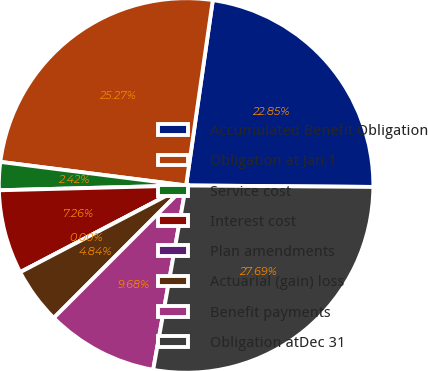<chart> <loc_0><loc_0><loc_500><loc_500><pie_chart><fcel>Accumulated Benefit Obligation<fcel>Obligation at Jan 1<fcel>Service cost<fcel>Interest cost<fcel>Plan amendments<fcel>Actuarial (gain) loss<fcel>Benefit payments<fcel>Obligation atDec 31<nl><fcel>22.85%<fcel>25.27%<fcel>2.42%<fcel>7.26%<fcel>0.0%<fcel>4.84%<fcel>9.68%<fcel>27.69%<nl></chart> 